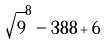<formula> <loc_0><loc_0><loc_500><loc_500>\sqrt { 9 } ^ { 8 } - 3 8 8 + 6</formula> 